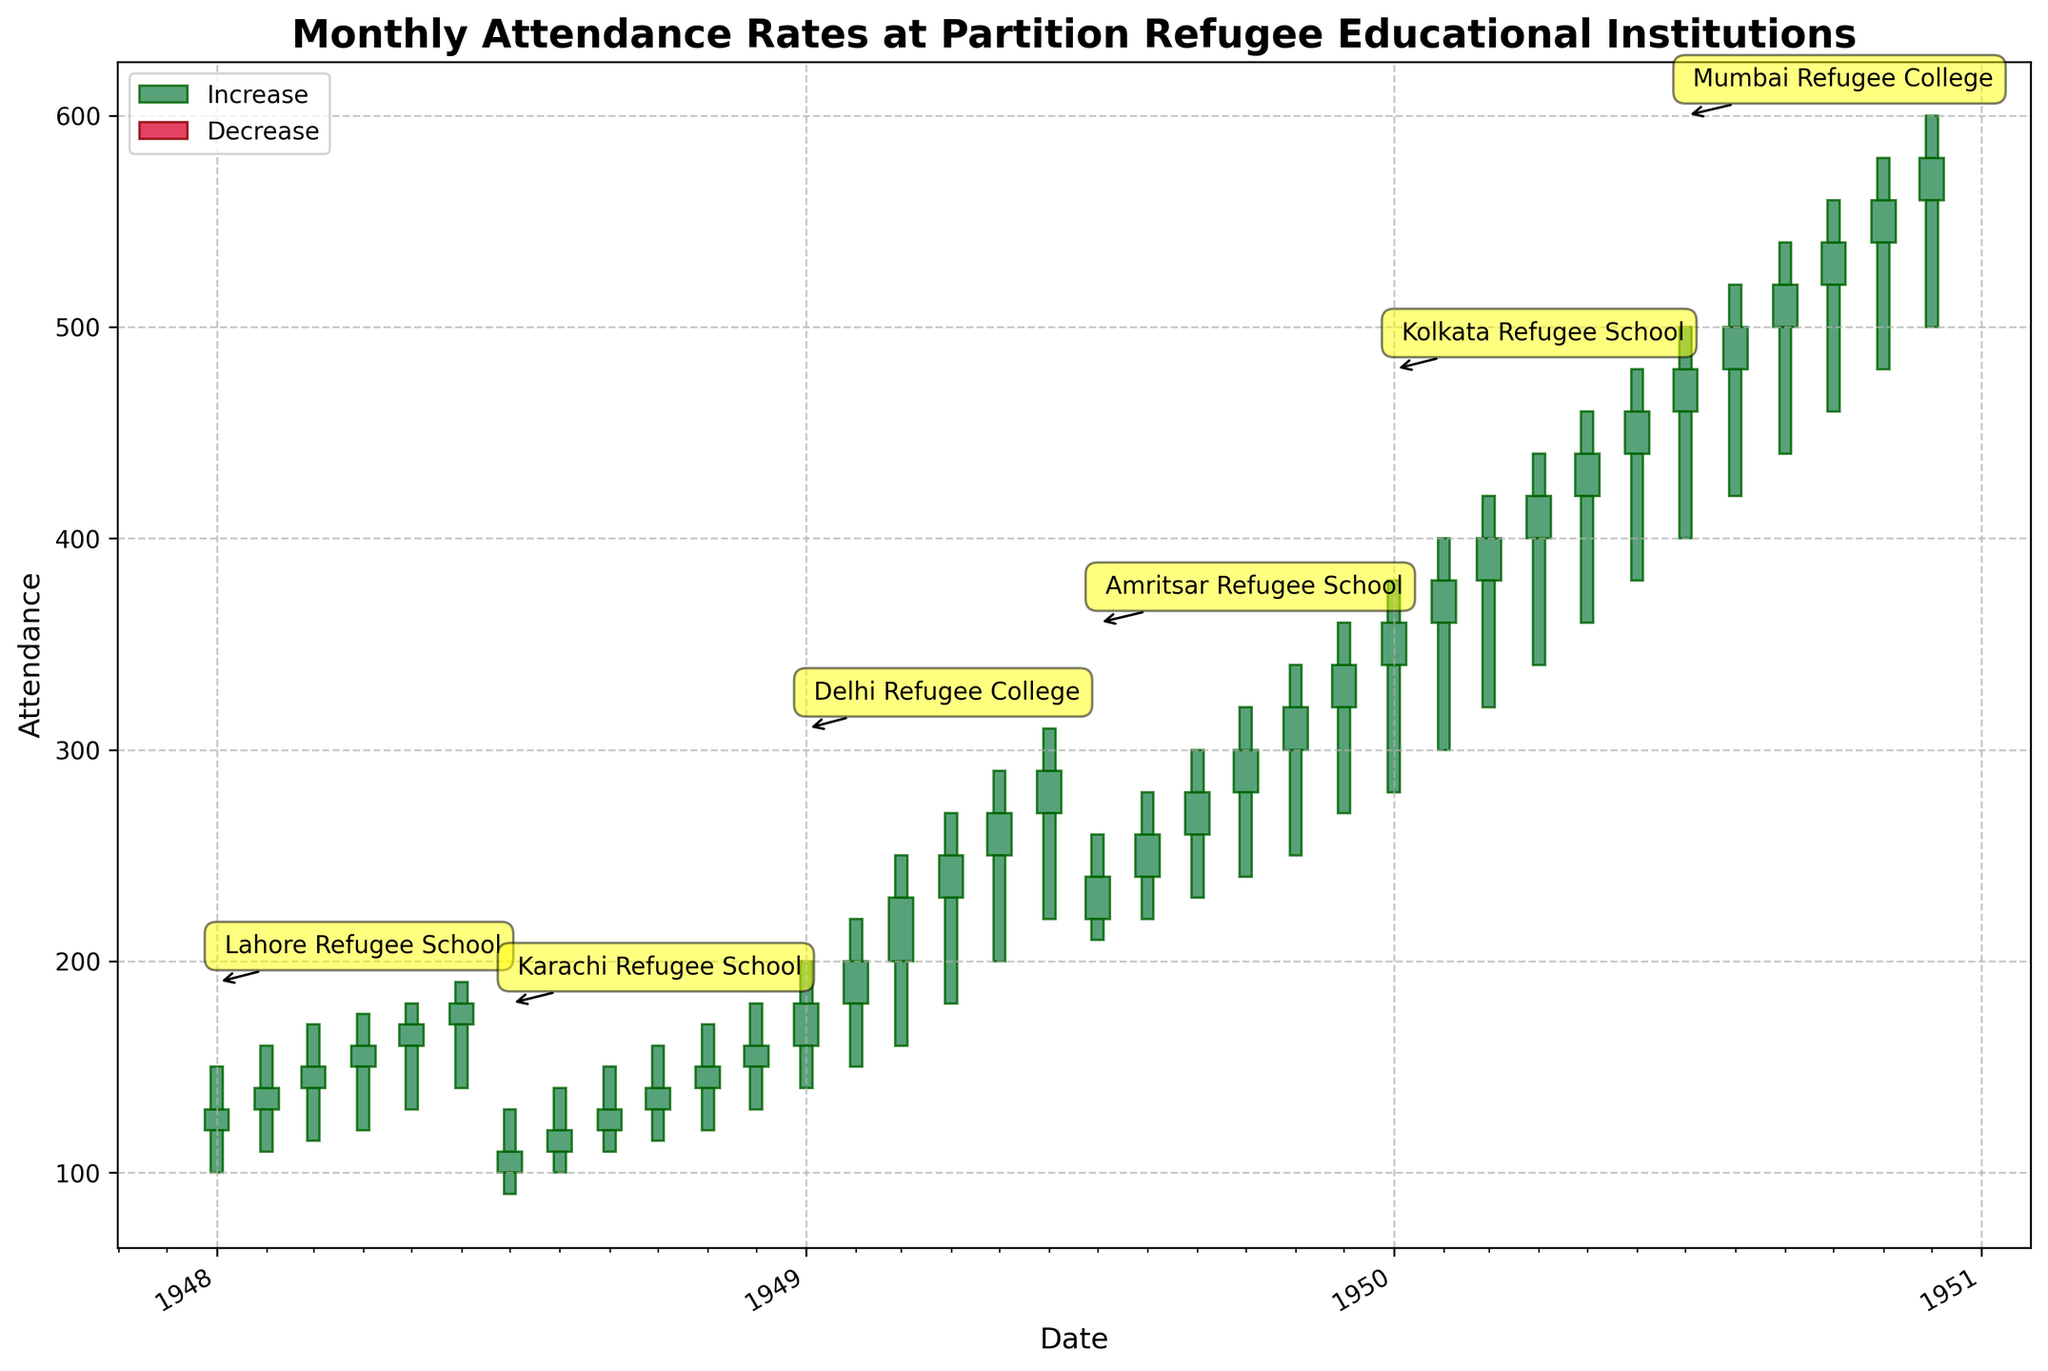What is the title of the figure? The title of the figure can be found at the top. It provides a brief description of the data being presented.
Answer: Monthly Attendance Rates at Partition Refugee Educational Institutions What is the maximum attendance recorded for any institution in any month? By looking at the highest point of the 'High' value in the figure, we see that the highest attendance recorded is for the Mumbai Refugee College in December 1950, which is 600.
Answer: 600 How many institutions' data are presented in the figure? There are annotations for each institution in the figure. Counting these annotations gives the total number of institutions.
Answer: 6 During which months did the Karachi Refugee School see a decrease in attendance? The down candlesticks, which are colored crimson, represent months where the close value is less than the open value. For Karachi Refugee School, these crimson bars are seen in July 1948.
Answer: July 1948 Which institution had the most consistent increase in attendance over the months? Consistent increase can be identified by observing continuous green candlesticks without any decrease. In the figure, Delhi Refugee College shows a continuous increase from January to June 1949.
Answer: Delhi Refugee College For the Lahore Refugee School, what is the total increase in attendance from the beginning (January 1948) to the end (June 1948)? The total increase can be found by subtracting the initial 'Open' value in January from the final 'Close' value in June. The initial open value is 120 and the final close value is 180. So, 180 - 120 = 60.
Answer: 60 How does the attendance trend for Amritsar Refugee School compare between its first and last recorded months? To compare the trend, look at the first and last month’s candlesticks for Amritsar Refugee School. The first month (July 1949) has a low of 210 and a high of 260, while the last month (December 1949) has a low of 270 and a high of 360. The attendance increased significantly from the first to the last month.
Answer: Increased significantly Which institution recorded the greatest monthly variability in attendance? Variability can be measured by examining the height of the candlesticks (difference between 'High' and 'Low') for each institution. The institution with the tallest candlesticks showcases the greatest variability, which is Mumbai Refugee College in September 1950 with a high of 540 and a low of 440, a difference of 100.
Answer: Mumbai Refugee College What annotation appears next to the highest attendance recorded on the plot? The annotations in the plot point out different institutions. The annotation next to the highest attendance recorded of 600 in December 1950 is 'Mumbai Refugee College'.
Answer: Mumbai Refugee College How did the attendance for Kolkata Refugee School change from January 1950 to June 1950? By observing the candlesticks of Kolkata Refugee School from January to June, we see continuous green bars indicating an increase. Starting with an open of 340 in January and closing at 460 in June.
Answer: Increased 